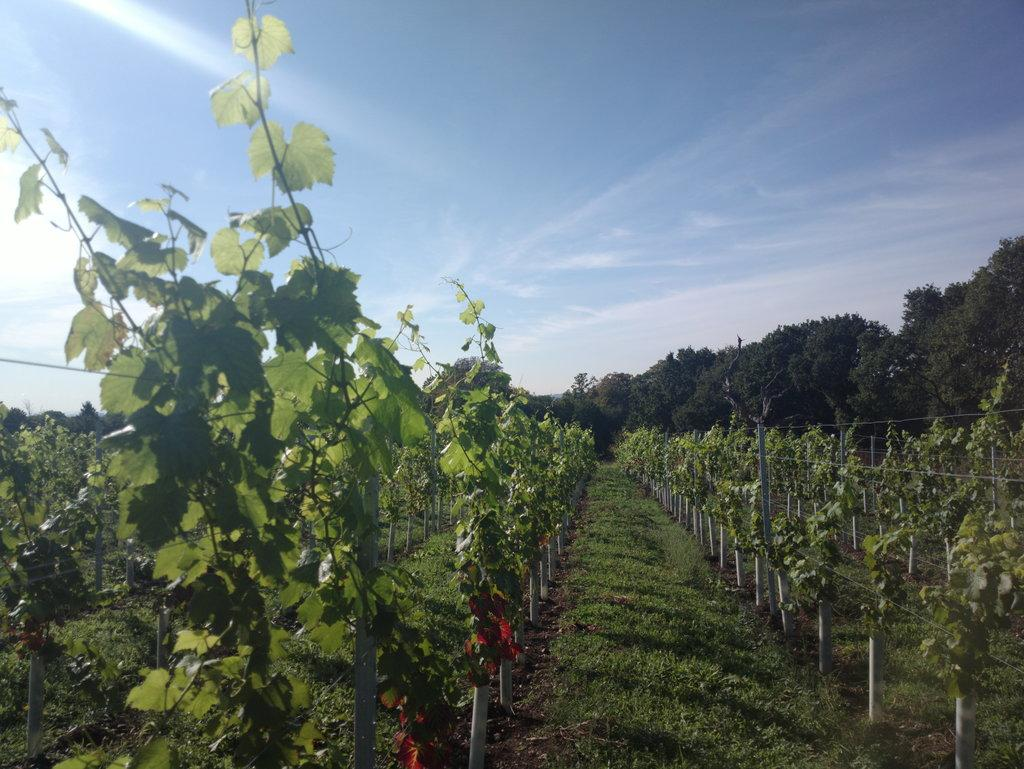What objects can be seen standing upright in the image? There are poles in the image. What type of vegetation is present in the image? There are green trees and grass visible in the image. What can be seen in the background of the image? There are trees and the sky visible in the background of the image. What type of spy equipment can be seen hidden in the trees in the image? There is no spy equipment present in the image; it only features poles, green trees, grass, and the sky in the background. 